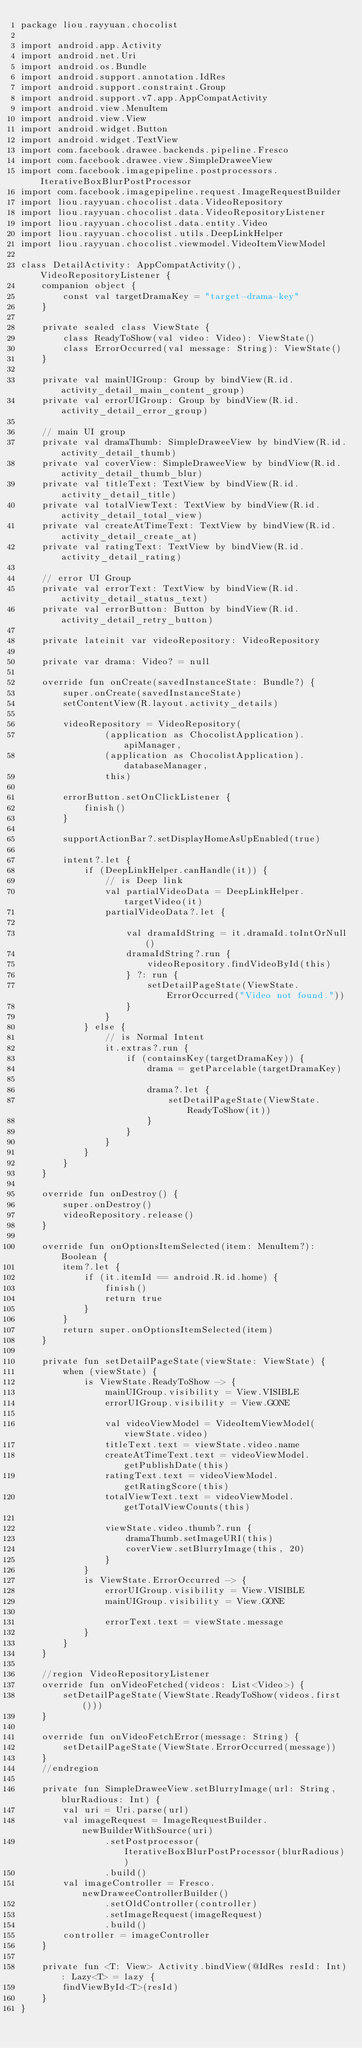<code> <loc_0><loc_0><loc_500><loc_500><_Kotlin_>package liou.rayyuan.chocolist

import android.app.Activity
import android.net.Uri
import android.os.Bundle
import android.support.annotation.IdRes
import android.support.constraint.Group
import android.support.v7.app.AppCompatActivity
import android.view.MenuItem
import android.view.View
import android.widget.Button
import android.widget.TextView
import com.facebook.drawee.backends.pipeline.Fresco
import com.facebook.drawee.view.SimpleDraweeView
import com.facebook.imagepipeline.postprocessors.IterativeBoxBlurPostProcessor
import com.facebook.imagepipeline.request.ImageRequestBuilder
import liou.rayyuan.chocolist.data.VideoRepository
import liou.rayyuan.chocolist.data.VideoRepositoryListener
import liou.rayyuan.chocolist.data.entity.Video
import liou.rayyuan.chocolist.utils.DeepLinkHelper
import liou.rayyuan.chocolist.viewmodel.VideoItemViewModel

class DetailActivity: AppCompatActivity(), VideoRepositoryListener {
    companion object {
        const val targetDramaKey = "target-drama-key"
    }

    private sealed class ViewState {
        class ReadyToShow(val video: Video): ViewState()
        class ErrorOccurred(val message: String): ViewState()
    }

    private val mainUIGroup: Group by bindView(R.id.activity_detail_main_content_group)
    private val errorUIGroup: Group by bindView(R.id.activity_detail_error_group)

    // main UI group
    private val dramaThumb: SimpleDraweeView by bindView(R.id.activity_detail_thumb)
    private val coverView: SimpleDraweeView by bindView(R.id.activity_detail_thumb_blur)
    private val titleText: TextView by bindView(R.id.activity_detail_title)
    private val totalViewText: TextView by bindView(R.id.activity_detail_total_view)
    private val createAtTimeText: TextView by bindView(R.id.activity_detail_create_at)
    private val ratingText: TextView by bindView(R.id.activity_detail_rating)

    // error UI Group
    private val errorText: TextView by bindView(R.id.activity_detail_status_text)
    private val errorButton: Button by bindView(R.id.activity_detail_retry_button)

    private lateinit var videoRepository: VideoRepository

    private var drama: Video? = null

    override fun onCreate(savedInstanceState: Bundle?) {
        super.onCreate(savedInstanceState)
        setContentView(R.layout.activity_details)

        videoRepository = VideoRepository(
                (application as ChocolistApplication).apiManager,
                (application as ChocolistApplication).databaseManager,
                this)

        errorButton.setOnClickListener {
            finish()
        }

        supportActionBar?.setDisplayHomeAsUpEnabled(true)

        intent?.let {
            if (DeepLinkHelper.canHandle(it)) {
                // is Deep link
                val partialVideoData = DeepLinkHelper.targetVideo(it)
                partialVideoData?.let {

                    val dramaIdString = it.dramaId.toIntOrNull()
                    dramaIdString?.run {
                        videoRepository.findVideoById(this)
                    } ?: run {
                        setDetailPageState(ViewState.ErrorOccurred("Video not found."))
                    }
                }
            } else {
                // is Normal Intent
                it.extras?.run {
                    if (containsKey(targetDramaKey)) {
                        drama = getParcelable(targetDramaKey)

                        drama?.let {
                            setDetailPageState(ViewState.ReadyToShow(it))
                        }
                    }
                }
            }
        }
    }

    override fun onDestroy() {
        super.onDestroy()
        videoRepository.release()
    }

    override fun onOptionsItemSelected(item: MenuItem?): Boolean {
        item?.let {
            if (it.itemId == android.R.id.home) {
                finish()
                return true
            }
        }
        return super.onOptionsItemSelected(item)
    }

    private fun setDetailPageState(viewState: ViewState) {
        when (viewState) {
            is ViewState.ReadyToShow -> {
                mainUIGroup.visibility = View.VISIBLE
                errorUIGroup.visibility = View.GONE

                val videoViewModel = VideoItemViewModel(viewState.video)
                titleText.text = viewState.video.name
                createAtTimeText.text = videoViewModel.getPublishDate(this)
                ratingText.text = videoViewModel.getRatingScore(this)
                totalViewText.text = videoViewModel.getTotalViewCounts(this)

                viewState.video.thumb?.run {
                    dramaThumb.setImageURI(this)
                    coverView.setBlurryImage(this, 20)
                }
            }
            is ViewState.ErrorOccurred -> {
                errorUIGroup.visibility = View.VISIBLE
                mainUIGroup.visibility = View.GONE

                errorText.text = viewState.message
            }
        }
    }

    //region VideoRepositoryListener
    override fun onVideoFetched(videos: List<Video>) {
        setDetailPageState(ViewState.ReadyToShow(videos.first()))
    }

    override fun onVideoFetchError(message: String) {
        setDetailPageState(ViewState.ErrorOccurred(message))
    }
    //endregion

    private fun SimpleDraweeView.setBlurryImage(url: String, blurRadious: Int) {
        val uri = Uri.parse(url)
        val imageRequest = ImageRequestBuilder.newBuilderWithSource(uri)
                .setPostprocessor(IterativeBoxBlurPostProcessor(blurRadious))
                .build()
        val imageController = Fresco.newDraweeControllerBuilder()
                .setOldController(controller)
                .setImageRequest(imageRequest)
                .build()
        controller = imageController
    }

    private fun <T: View> Activity.bindView(@IdRes resId: Int): Lazy<T> = lazy {
        findViewById<T>(resId)
    }
}</code> 